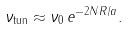<formula> <loc_0><loc_0><loc_500><loc_500>\nu _ { \text {tun} } \approx \nu _ { 0 } \, e ^ { - 2 N R / a } .</formula> 